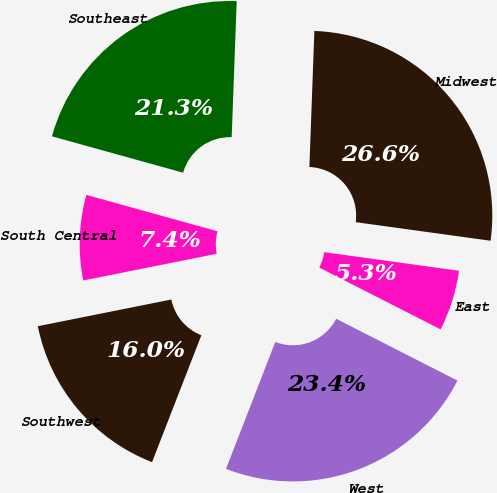Convert chart to OTSL. <chart><loc_0><loc_0><loc_500><loc_500><pie_chart><fcel>East<fcel>Midwest<fcel>Southeast<fcel>South Central<fcel>Southwest<fcel>West<nl><fcel>5.32%<fcel>26.6%<fcel>21.28%<fcel>7.45%<fcel>15.96%<fcel>23.4%<nl></chart> 